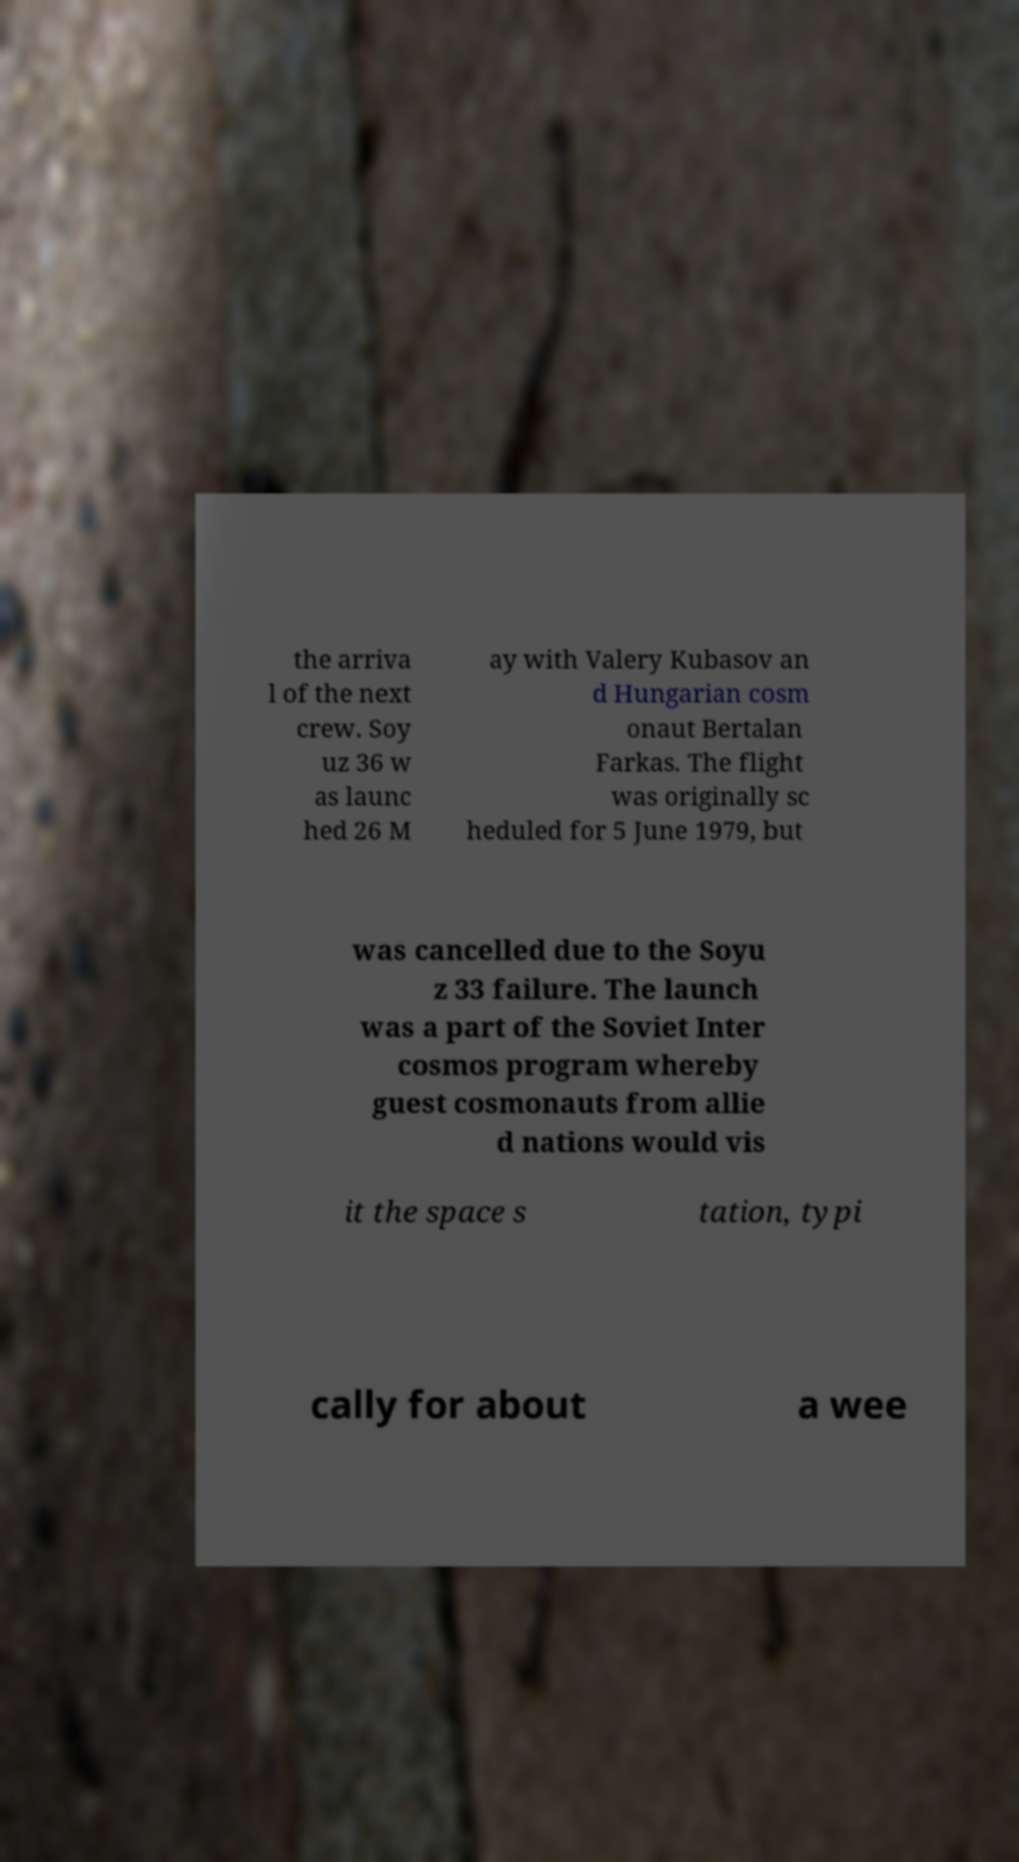Can you read and provide the text displayed in the image?This photo seems to have some interesting text. Can you extract and type it out for me? the arriva l of the next crew. Soy uz 36 w as launc hed 26 M ay with Valery Kubasov an d Hungarian cosm onaut Bertalan Farkas. The flight was originally sc heduled for 5 June 1979, but was cancelled due to the Soyu z 33 failure. The launch was a part of the Soviet Inter cosmos program whereby guest cosmonauts from allie d nations would vis it the space s tation, typi cally for about a wee 